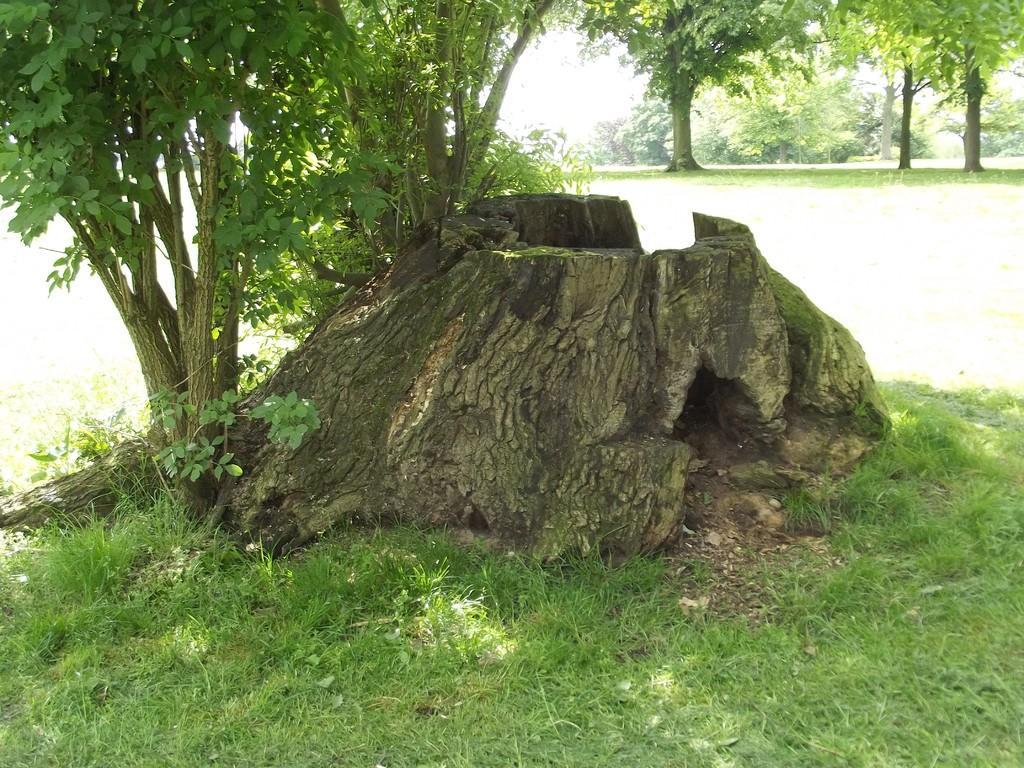Please provide a concise description of this image. This picture is clicked outside. In the foreground we can see the green grass and a rock. On the left we can see the plants and the trees. In the background there is a ground, trees plants and the grass. 